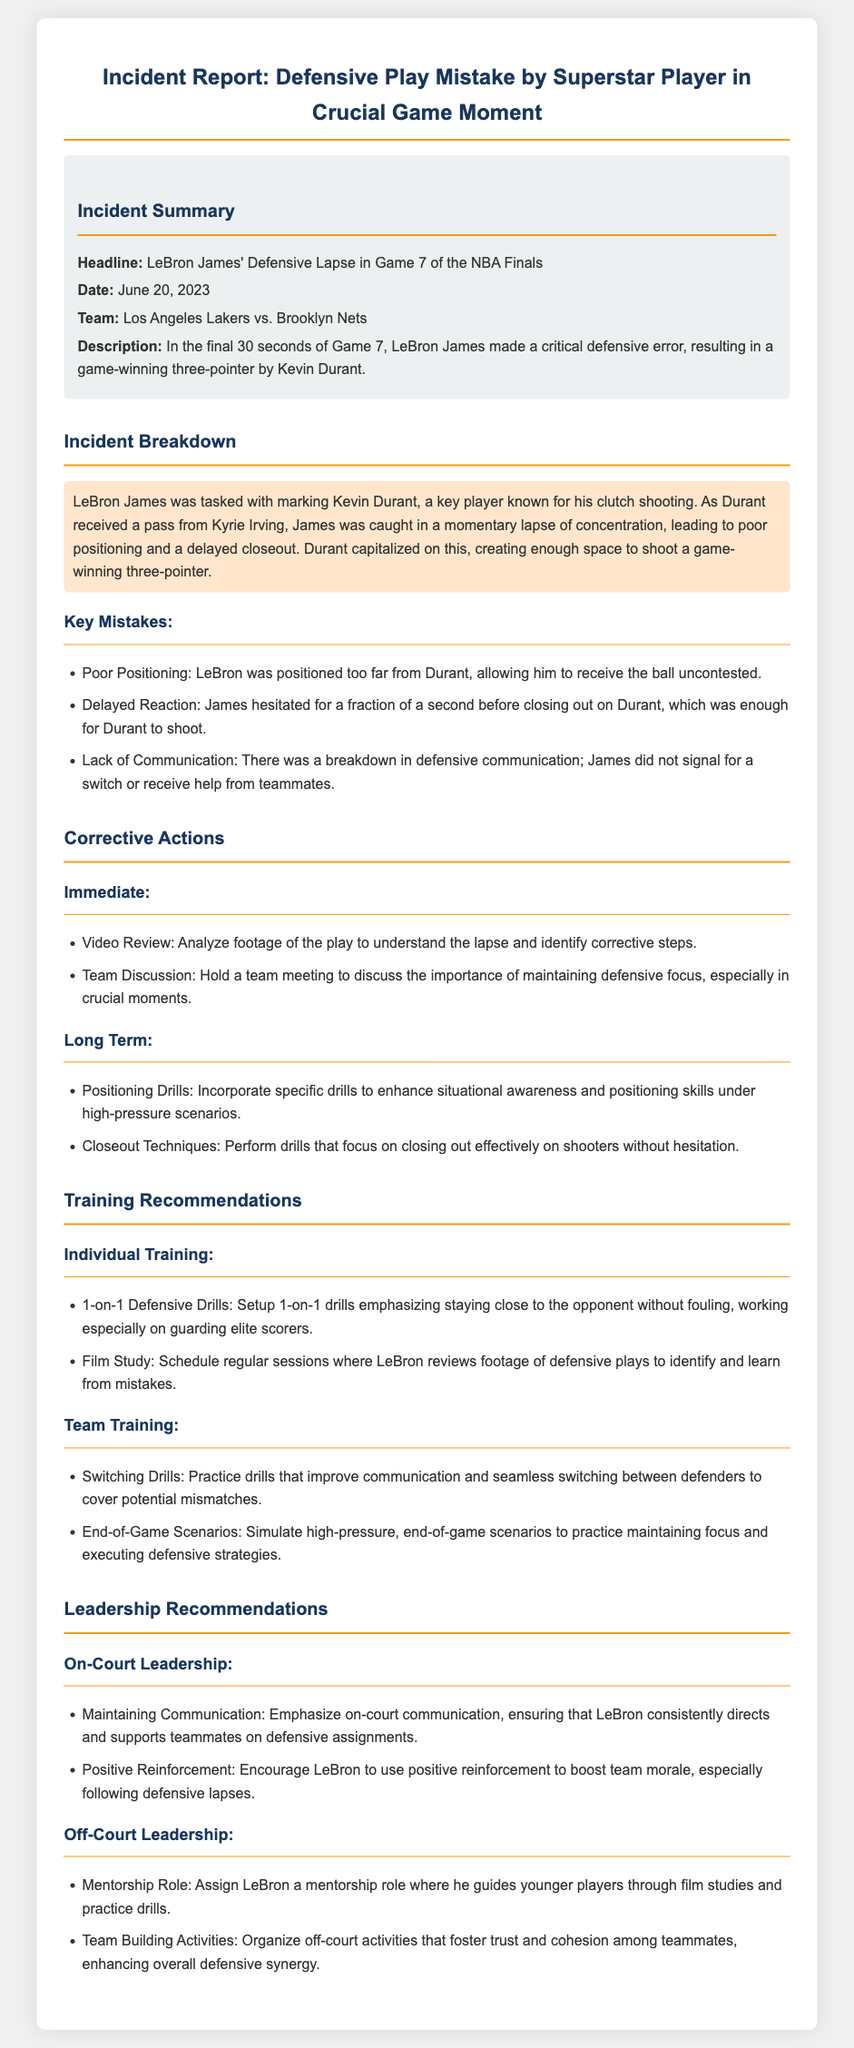what is the date of the incident? The date of the incident is clearly stated in the incident summary section.
Answer: June 20, 2023 who made the critical defensive error? The document specifies that LeBron James was the one who made the defensive error.
Answer: LeBron James what was the key mistake made by LeBron? The document lists multiple mistakes, with poor positioning being one highlighted in the incident breakdown.
Answer: Poor Positioning what should be incorporated to enhance situational awareness? The corrective actions section recommends drills specifically focused on situational awareness.
Answer: Positioning Drills what type of drills are recommended for LeBron's individual training? The training recommendations include 1-on-1 drills emphasizing defense.
Answer: 1-on-1 Defensive Drills what is one of the leadership roles suggested for LeBron? The leadership recommendations propose that LeBron take on a mentorship role.
Answer: Mentorship Role what action is suggested for team training regarding defensive assignments? The document advises practicing switching drills to improve communication.
Answer: Switching Drills how many seconds were left in the game during the critical moment? The incident description notes the time left in the game when the error occurred.
Answer: 30 seconds 